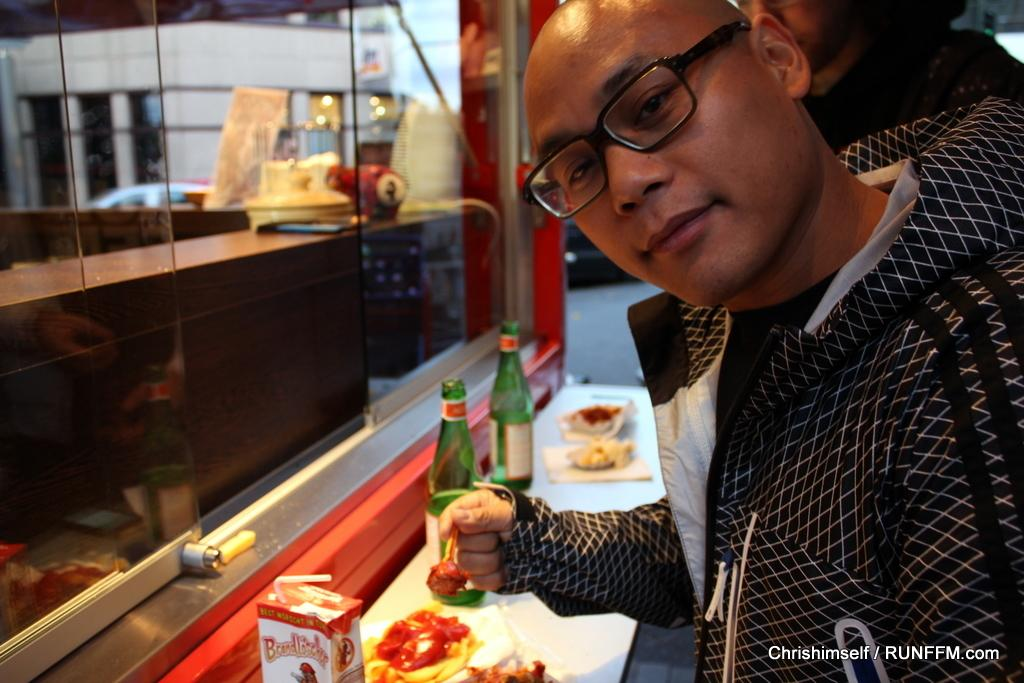How many people are in the image? There are two people in the image. What are the people doing in the image? The people are standing in front of a table. What can be seen on the table in the image? There are food items and bottles on the table. What is visible on the left side of the image? There is a glass door on the left side of the image. What type of sand can be seen on the table in the image? There is no sand present on the table in the image. Are the people in the image sleeping or participating in a war? The image does not depict any sleeping or war-related activities; the people are simply standing in front of a table. 